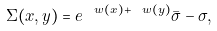Convert formula to latex. <formula><loc_0><loc_0><loc_500><loc_500>\Sigma ( x , y ) = e ^ { \ w ( x ) + \ w ( y ) } \bar { \sigma } - \sigma ,</formula> 